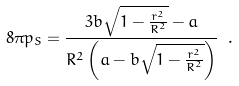<formula> <loc_0><loc_0><loc_500><loc_500>8 \pi p _ { S } = \frac { 3 b \sqrt { 1 - \frac { r ^ { 2 } } { R ^ { 2 } } } - a } { R ^ { 2 } \left ( a - b \sqrt { 1 - \frac { r ^ { 2 } } { R ^ { 2 } } } \right ) } \ .</formula> 